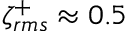Convert formula to latex. <formula><loc_0><loc_0><loc_500><loc_500>\zeta _ { r m s } ^ { + } \approx 0 . 5</formula> 